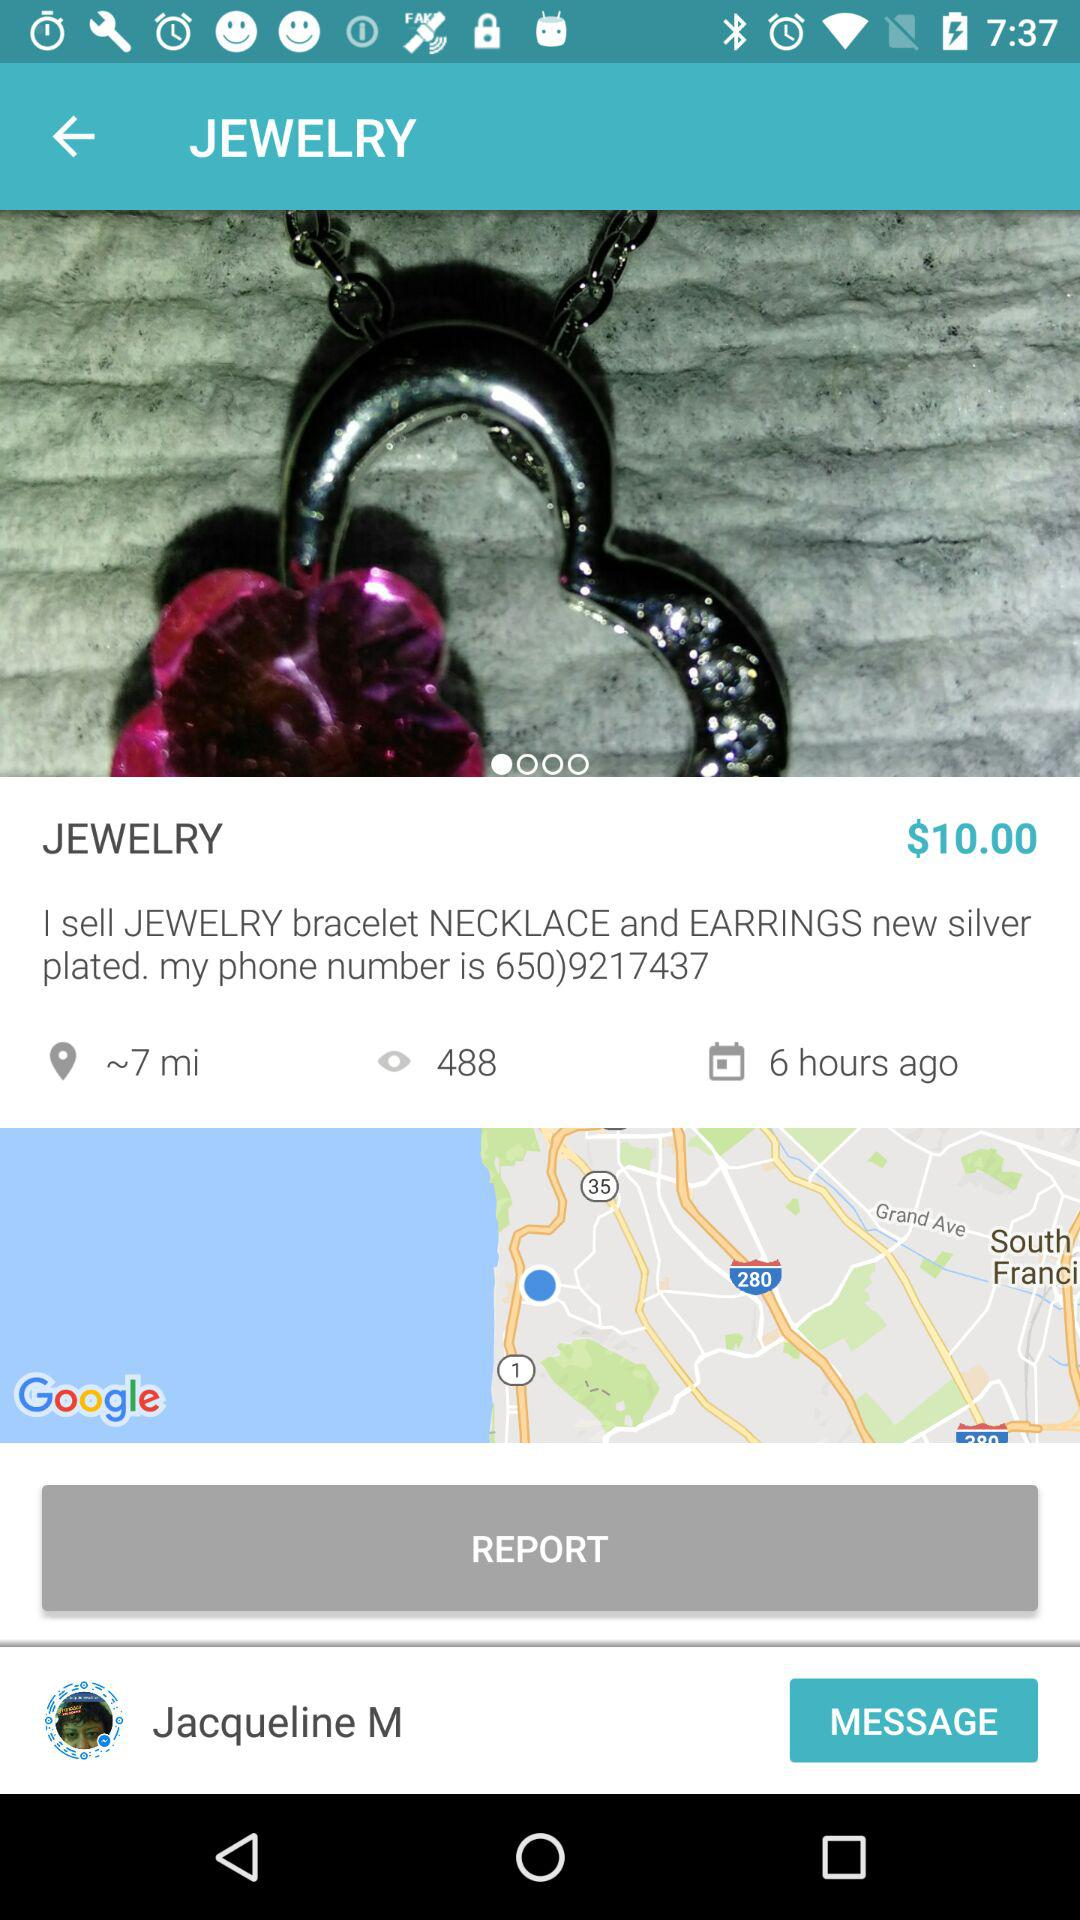What is the "JEWELRY" price? The "JEWELRY" price is $10. 